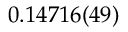Convert formula to latex. <formula><loc_0><loc_0><loc_500><loc_500>0 . 1 4 7 1 6 ( 4 9 )</formula> 